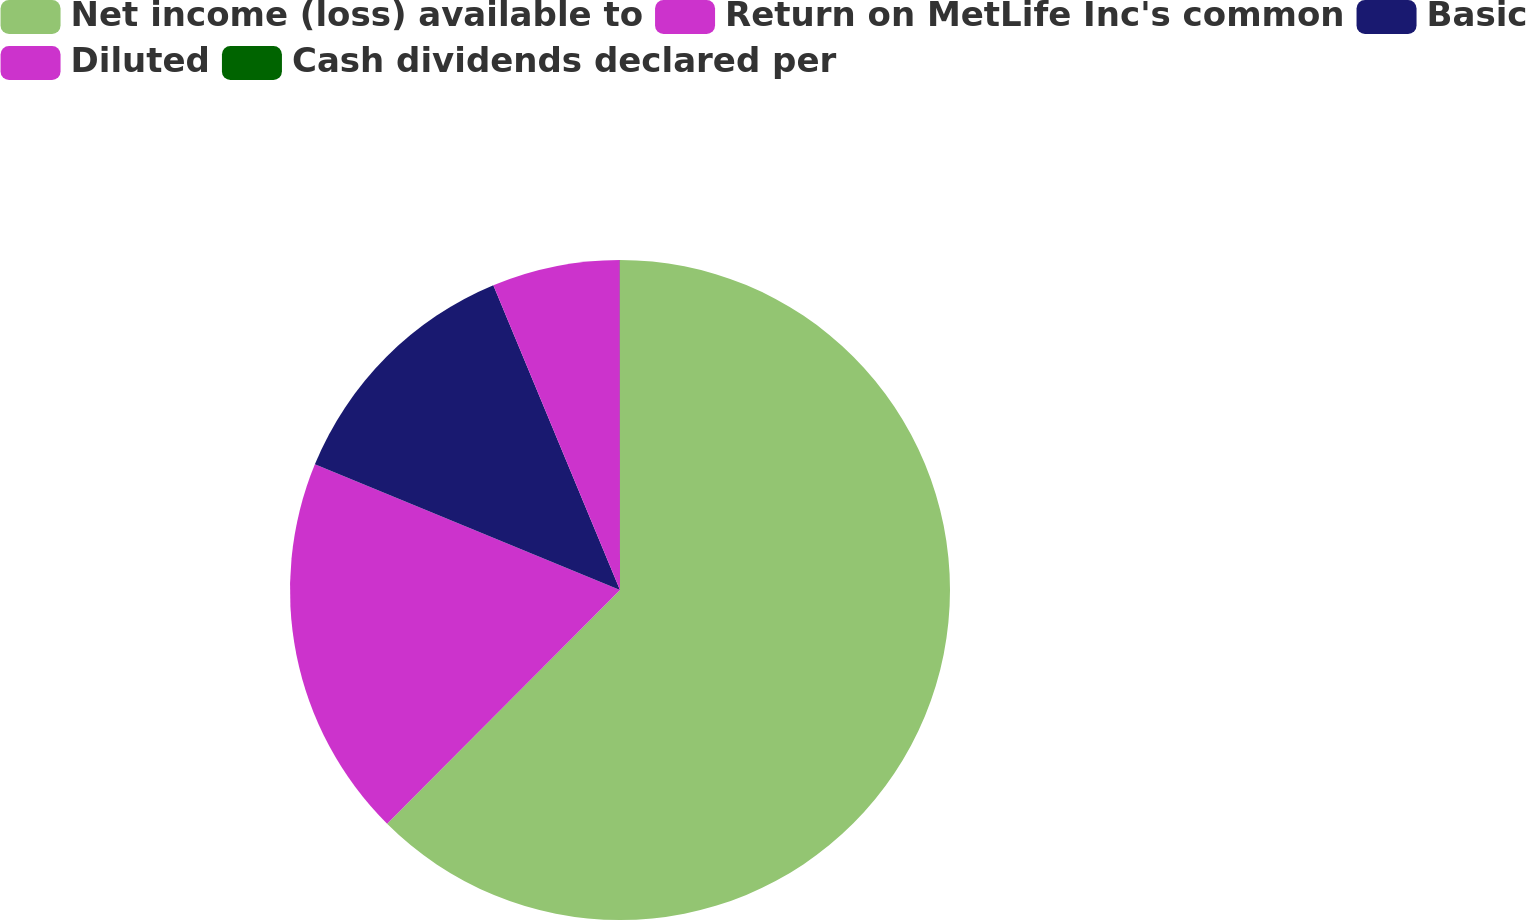Convert chart to OTSL. <chart><loc_0><loc_0><loc_500><loc_500><pie_chart><fcel>Net income (loss) available to<fcel>Return on MetLife Inc's common<fcel>Basic<fcel>Diluted<fcel>Cash dividends declared per<nl><fcel>62.47%<fcel>18.75%<fcel>12.51%<fcel>6.26%<fcel>0.01%<nl></chart> 